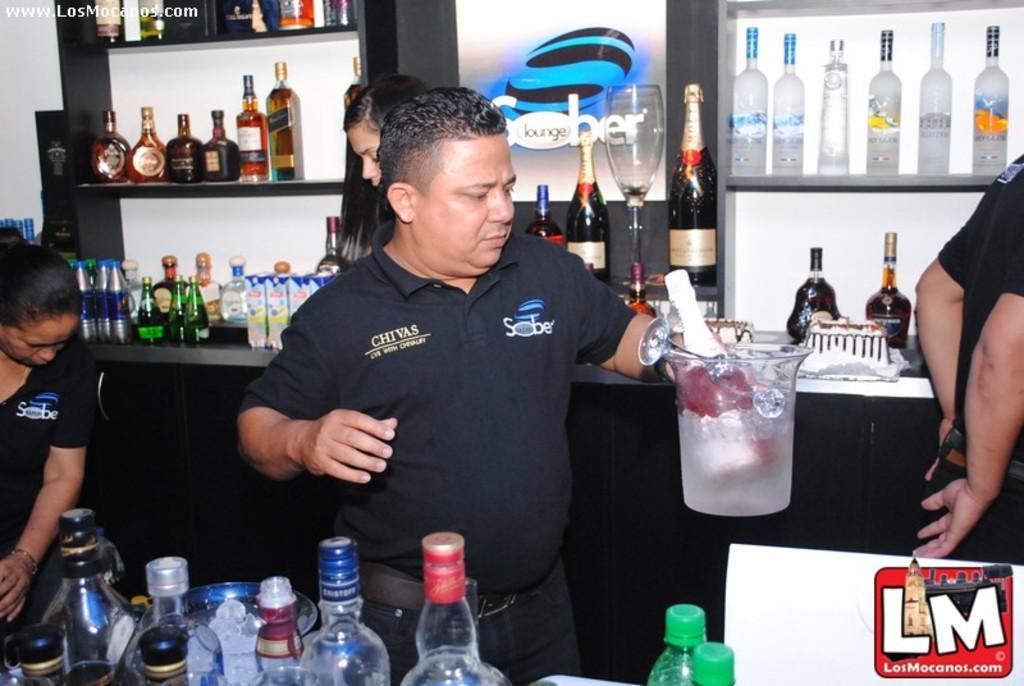In one or two sentences, can you explain what this image depicts? There are four people inside the bar counter. A man is carrying a jar with ice and champagne bottle in it. 